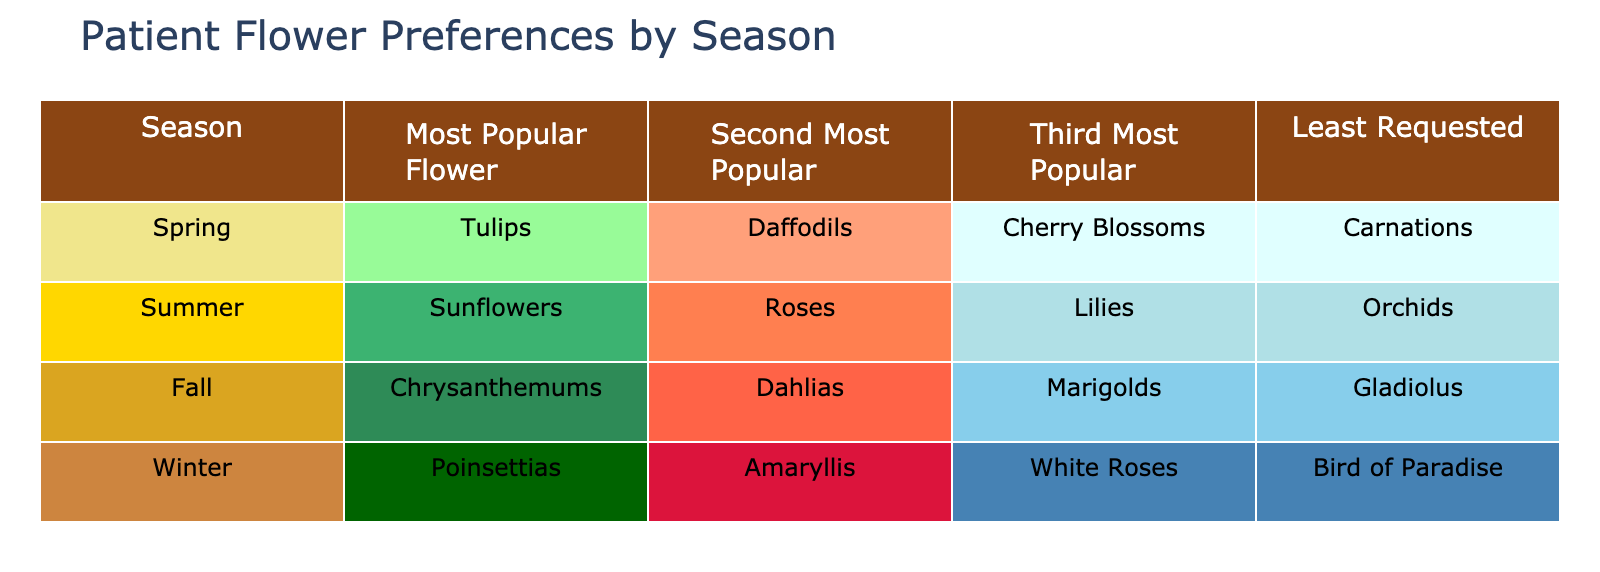What is the most popular flower in Spring? According to the table, the most popular flower in Spring is listed in the corresponding row under the column "Most Popular Flower." It states "Tulips" as that flower.
Answer: Tulips Which flower is least requested in Fall? The table indicates that in Fall, the "Least Requested" flower is specified under that column for the Fall row. It mentions "Gladiolus" as the least requested flower.
Answer: Gladiolus Are Roses more popular than Lilies in Summer? In the Summer row, Roses are categorized under the "Second Most Popular" flower while Lilies are under the "Third Most Popular." Hence, Roses are indeed more popular than Lilies in that season.
Answer: Yes What are the top three flowers in Winter? The Winter row provides the top three flowers listed sequentially under the "Most Popular," "Second Most Popular," and "Third Most Popular" columns, which are "Poinsettias," "Amaryllis," and "White Roses" respectively.
Answer: Poinsettias, Amaryllis, White Roses Which season has the least requested flower as Carnations? To determine the season that lists Carnations as the least requested flower, we check the "Least Requested" column across all seasons and find that it is associated with Spring.
Answer: Spring What is the average popularity ranking of flowers in the Summer? In Summer, the rankings for "Sunflowers," "Roses," "Lilies," and "Orchids" are 1, 2, 3, and 4 respectively. To find the average ranking: (1 + 2 + 3 + 4) / 4 = 2.5.
Answer: 2.5 Is White Roses requested more than Poinsettias in Winter? Looking at the Winter row, "Poinsettias" are the most popular and "White Roses" are the third most popular. Since first place is more requested than third, the answer is no.
Answer: No Which flower has similar popularity in both Spring and Fall? By examining both seasons, we see that Daffodils in Spring and Dahlias in Fall appear under the second most popular column. However, they are different flowers, so no similar popularity exists.
Answer: None 